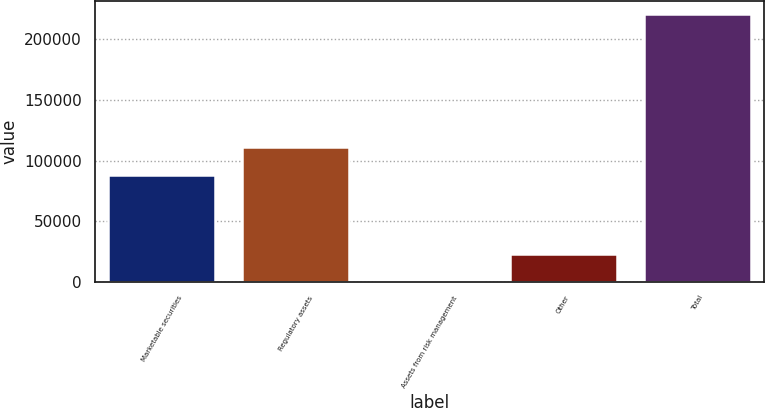Convert chart to OTSL. <chart><loc_0><loc_0><loc_500><loc_500><bar_chart><fcel>Marketable securities<fcel>Regulatory assets<fcel>Assets from risk management<fcel>Other<fcel>Total<nl><fcel>88409<fcel>110977<fcel>803<fcel>22786.3<fcel>220636<nl></chart> 